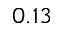<formula> <loc_0><loc_0><loc_500><loc_500>0 . 1 3</formula> 